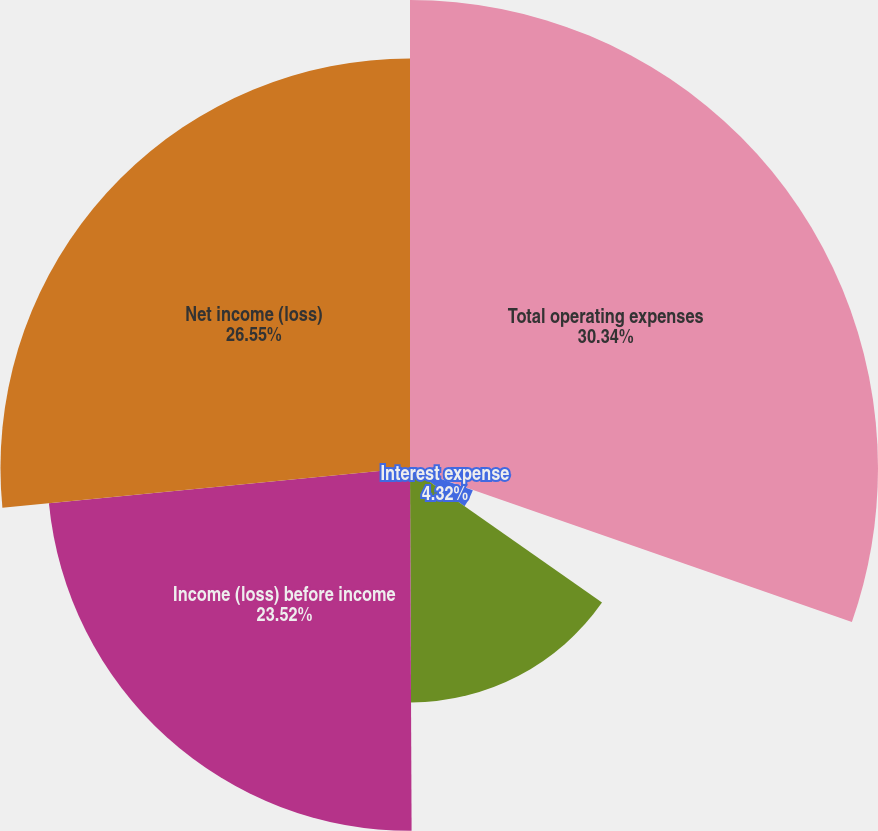Convert chart to OTSL. <chart><loc_0><loc_0><loc_500><loc_500><pie_chart><fcel>Total operating expenses<fcel>Interest income<fcel>Interest expense<fcel>Other income (expense) net<fcel>Income (loss) before income<fcel>Net income (loss)<nl><fcel>30.34%<fcel>0.07%<fcel>4.32%<fcel>15.2%<fcel>23.52%<fcel>26.55%<nl></chart> 